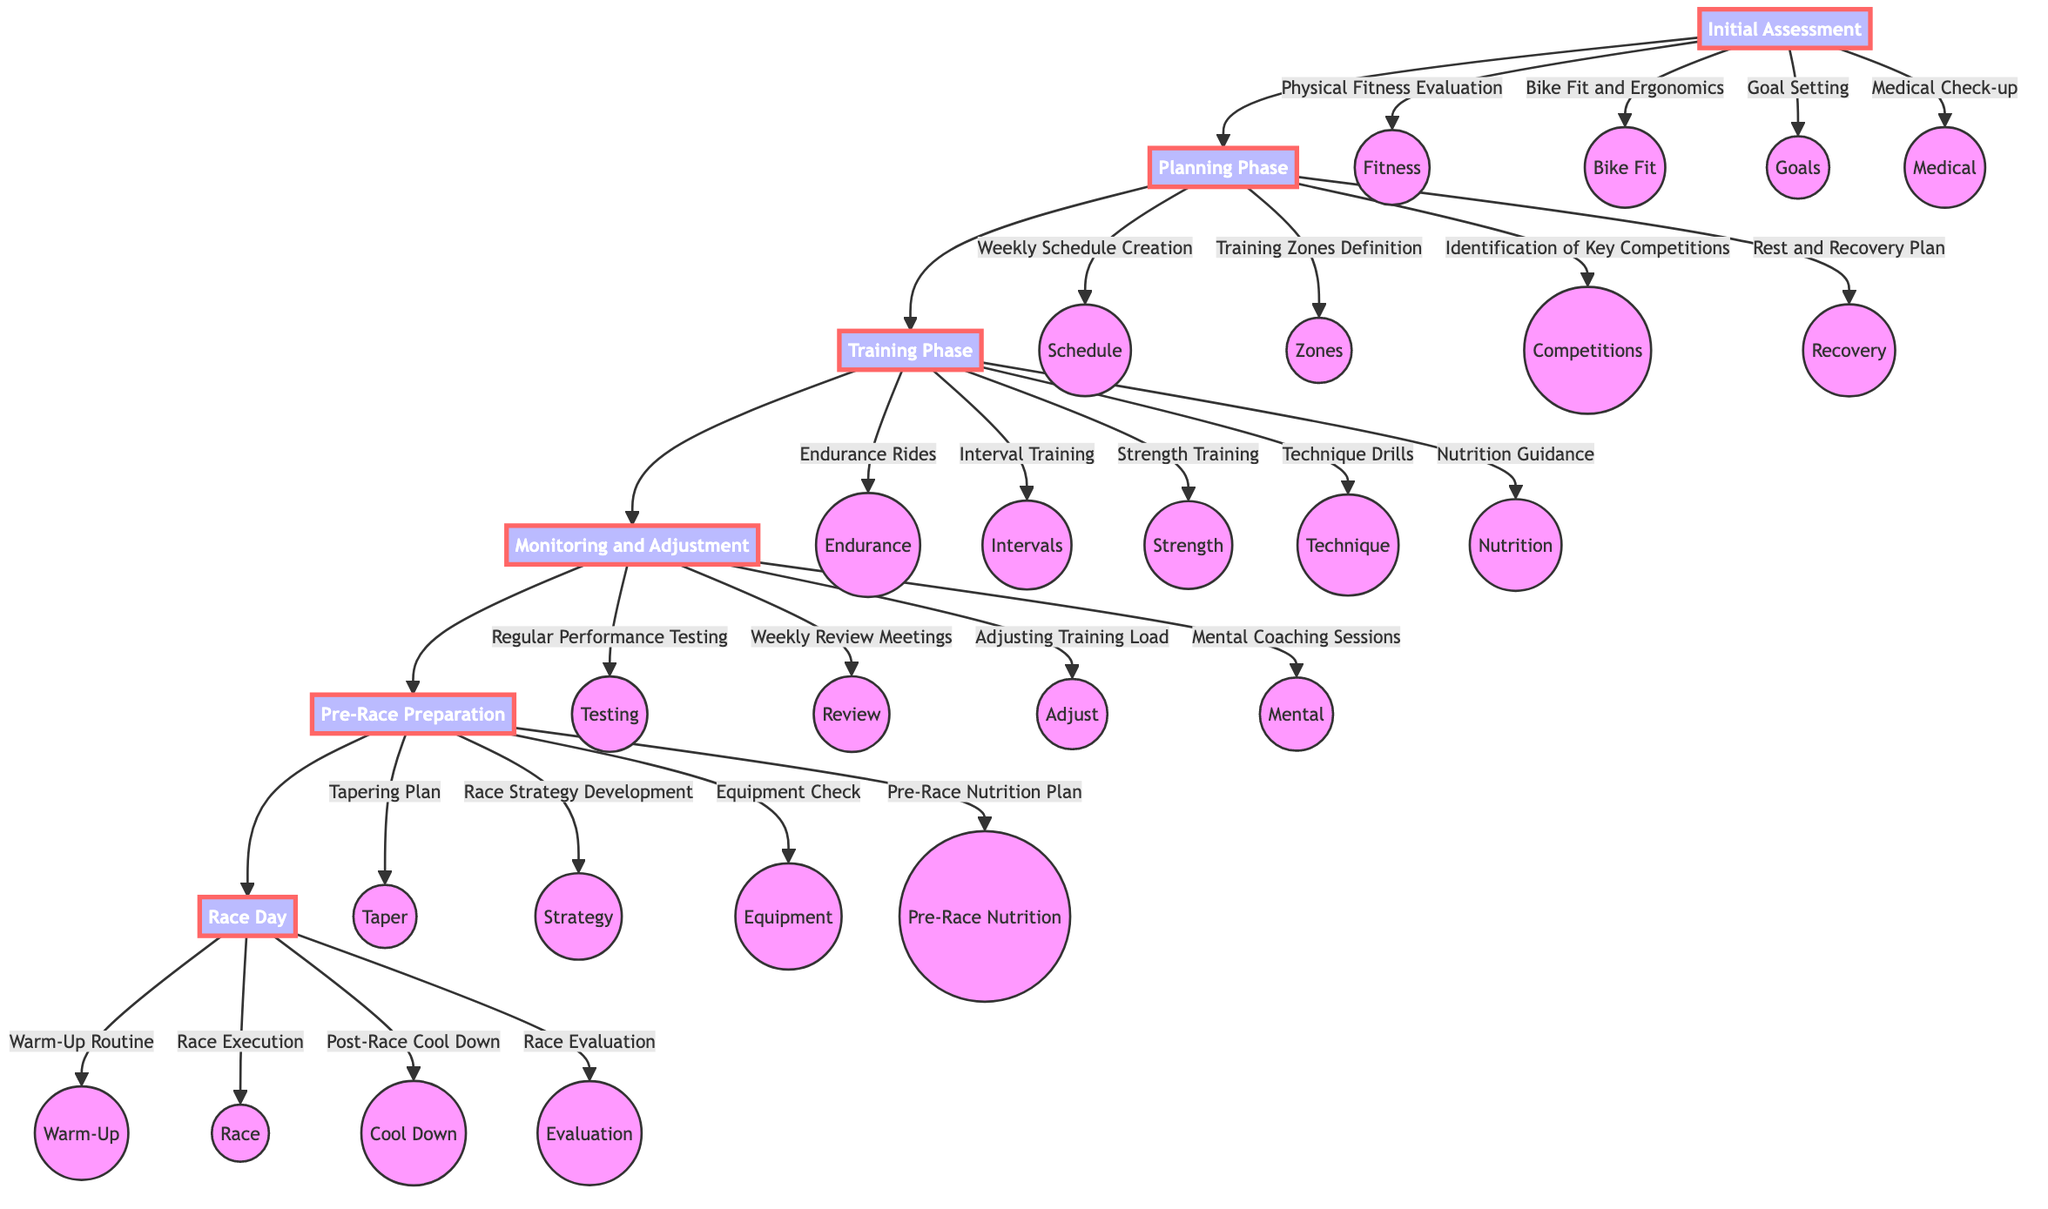What is the first stage in the training program development? The diagram indicates that the first stage is "Initial Assessment," which is the starting point of the flowchart.
Answer: Initial Assessment How many elements are included in the "Planning Phase"? Analyzing the diagram shows that there are four elements listed under the "Planning Phase," namely Weekly Schedule Creation, Training Zones Definition, Identification of Key Competitions, and Rest and Recovery Plan.
Answer: 4 Which stage follows the "Training Phase"? Observing the flow of the diagram, "Monitoring and Adjustment" is directly connected to the "Training Phase," indicating that it is the next stage.
Answer: Monitoring and Adjustment What type of training is included in the "Training Phase"? Looking at the elements in the "Training Phase," it includes Endurance Rides, Interval Training, Strength Training, Technique Drills, and Nutrition Guidance, which are all specific types of training activities.
Answer: Endurance Rides, Interval Training, Strength Training, Technique Drills, Nutrition Guidance What is one component of the "Pre-Race Preparation"? The diagram lists several components under "Pre-Race Preparation," one of which is "Tapering Plan," showcasing an essential part of getting ready for an event.
Answer: Tapering Plan In the "Monitoring and Adjustment" stage, which element involves performance assessment? The element "Regular Performance Testing" mentioned in the "Monitoring and Adjustment" stage focuses specifically on assessing the performance regularly throughout the training program.
Answer: Regular Performance Testing How many stages are there in total in the training program development? Counting each distinct stage in the flowchart, we find there are six stages labeled from "Initial Assessment" to "Race Day."
Answer: 6 What is the final stage of the training program development? The last stage visible in the flowchart is "Race Day," indicating it is the final step before the athlete competes.
Answer: Race Day What type of session is included under "Monitoring and Adjustment" for mental preparation? The flowchart specifies "Mental Coaching Sessions" as one of the components, indicating an aspect of mental preparation during the training adjustment phase.
Answer: Mental Coaching Sessions 